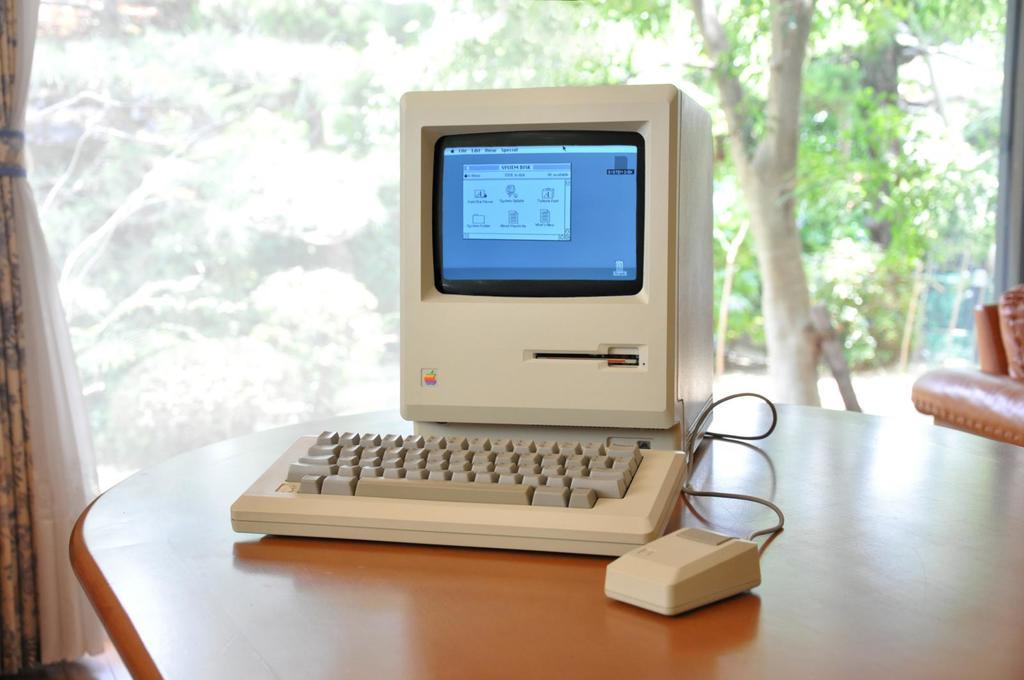What is the main object in the image? There is a machine in the image. What is used to interact with the machine? There is a keyboard and a mouse in the image, which are used to interact with the machine. Where are the machine, keyboard, and mouse located? They are placed on a table in the image. What can be seen in the background of the image? There are curtains, a glass window, and trees visible through the glass window in the background of the image. What type of earth can be seen in the garden through the glass window? There is no garden present in the image, and therefore no earth can be seen through the glass window. 